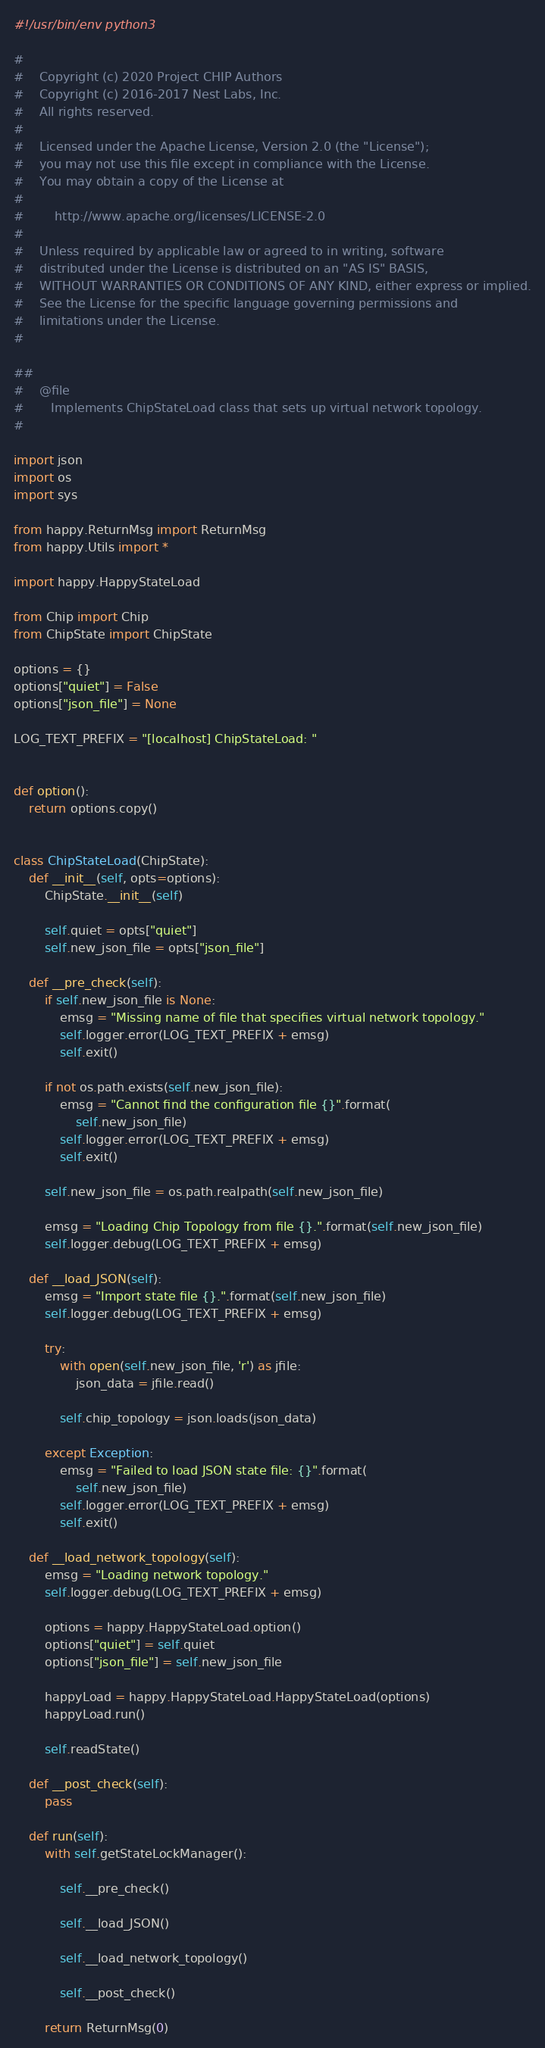Convert code to text. <code><loc_0><loc_0><loc_500><loc_500><_Python_>#!/usr/bin/env python3

#
#    Copyright (c) 2020 Project CHIP Authors
#    Copyright (c) 2016-2017 Nest Labs, Inc.
#    All rights reserved.
#
#    Licensed under the Apache License, Version 2.0 (the "License");
#    you may not use this file except in compliance with the License.
#    You may obtain a copy of the License at
#
#        http://www.apache.org/licenses/LICENSE-2.0
#
#    Unless required by applicable law or agreed to in writing, software
#    distributed under the License is distributed on an "AS IS" BASIS,
#    WITHOUT WARRANTIES OR CONDITIONS OF ANY KIND, either express or implied.
#    See the License for the specific language governing permissions and
#    limitations under the License.
#

##
#    @file
#       Implements ChipStateLoad class that sets up virtual network topology.
#

import json
import os
import sys

from happy.ReturnMsg import ReturnMsg
from happy.Utils import *

import happy.HappyStateLoad

from Chip import Chip
from ChipState import ChipState

options = {}
options["quiet"] = False
options["json_file"] = None

LOG_TEXT_PREFIX = "[localhost] ChipStateLoad: "


def option():
    return options.copy()


class ChipStateLoad(ChipState):
    def __init__(self, opts=options):
        ChipState.__init__(self)

        self.quiet = opts["quiet"]
        self.new_json_file = opts["json_file"]

    def __pre_check(self):
        if self.new_json_file is None:
            emsg = "Missing name of file that specifies virtual network topology."
            self.logger.error(LOG_TEXT_PREFIX + emsg)
            self.exit()

        if not os.path.exists(self.new_json_file):
            emsg = "Cannot find the configuration file {}".format(
                self.new_json_file)
            self.logger.error(LOG_TEXT_PREFIX + emsg)
            self.exit()

        self.new_json_file = os.path.realpath(self.new_json_file)

        emsg = "Loading Chip Topology from file {}.".format(self.new_json_file)
        self.logger.debug(LOG_TEXT_PREFIX + emsg)

    def __load_JSON(self):
        emsg = "Import state file {}.".format(self.new_json_file)
        self.logger.debug(LOG_TEXT_PREFIX + emsg)

        try:
            with open(self.new_json_file, 'r') as jfile:
                json_data = jfile.read()

            self.chip_topology = json.loads(json_data)

        except Exception:
            emsg = "Failed to load JSON state file: {}".format(
                self.new_json_file)
            self.logger.error(LOG_TEXT_PREFIX + emsg)
            self.exit()

    def __load_network_topology(self):
        emsg = "Loading network topology."
        self.logger.debug(LOG_TEXT_PREFIX + emsg)

        options = happy.HappyStateLoad.option()
        options["quiet"] = self.quiet
        options["json_file"] = self.new_json_file

        happyLoad = happy.HappyStateLoad.HappyStateLoad(options)
        happyLoad.run()

        self.readState()

    def __post_check(self):
        pass

    def run(self):
        with self.getStateLockManager():

            self.__pre_check()

            self.__load_JSON()

            self.__load_network_topology()

            self.__post_check()

        return ReturnMsg(0)
</code> 